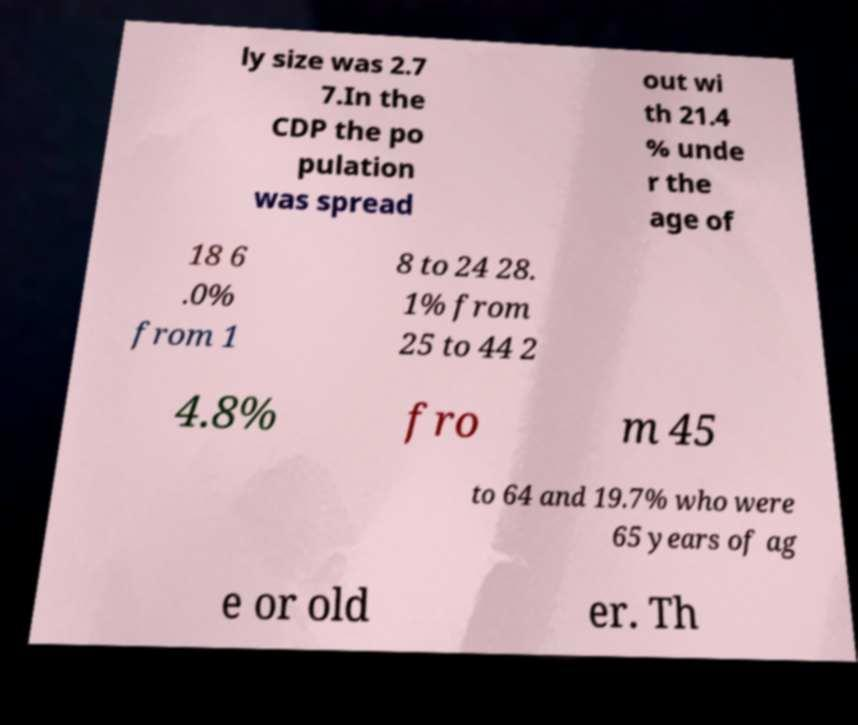Please read and relay the text visible in this image. What does it say? ly size was 2.7 7.In the CDP the po pulation was spread out wi th 21.4 % unde r the age of 18 6 .0% from 1 8 to 24 28. 1% from 25 to 44 2 4.8% fro m 45 to 64 and 19.7% who were 65 years of ag e or old er. Th 